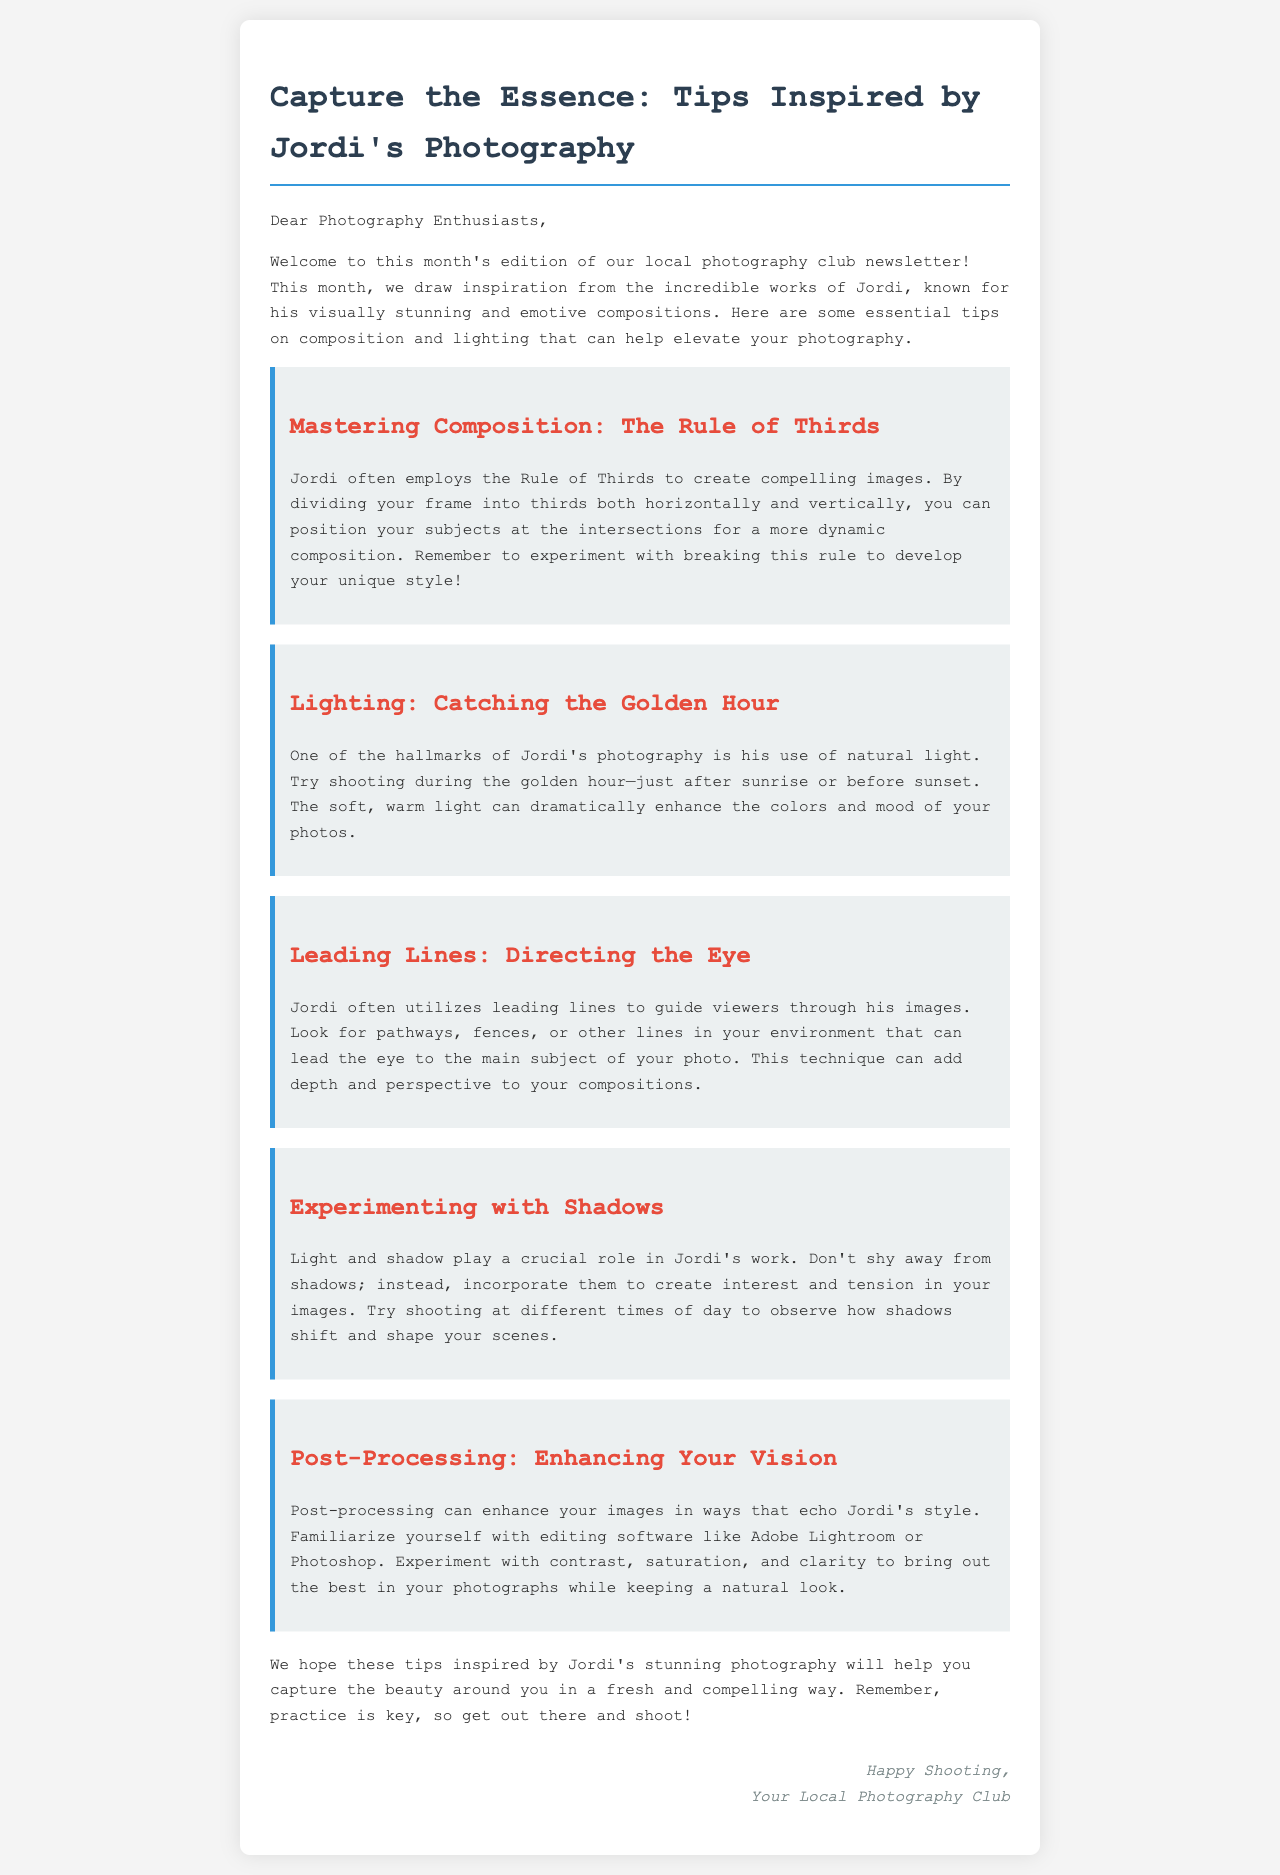What is the title of the newsletter? The title is prominently displayed in the heading of the document.
Answer: Capture the Essence: Tips Inspired by Jordi's Photography Who is the photographer inspiring the tips? The document states that the tips are inspired by the works of a specific photographer.
Answer: Jordi What is one composition technique mentioned? The document lists different tips for composition, one of which is highlighted.
Answer: The Rule of Thirds What lighting time is recommended? The newsletter advises shooting during a specific time for optimal lighting.
Answer: Golden Hour Which editing software is suggested for post-processing? The document recommends familiarizing oneself with certain software for enhancing images.
Answer: Adobe Lightroom or Photoshop What is a key aspect of Jordi's photography style? The document emphasizes several techniques used by Jordi, revealing a significant feature of his style.
Answer: Natural Light What does the newsletter encourage readers to do? The document concludes with a call to action for the readers.
Answer: Practice How does Jordi use lines in his photography? The document explains a specific technique employed by Jordi regarding composition.
Answer: Leading Lines What should photographers avoid according to the newsletter? The document mentions a common element that photographers shouldn't shy away from using.
Answer: Shadows 